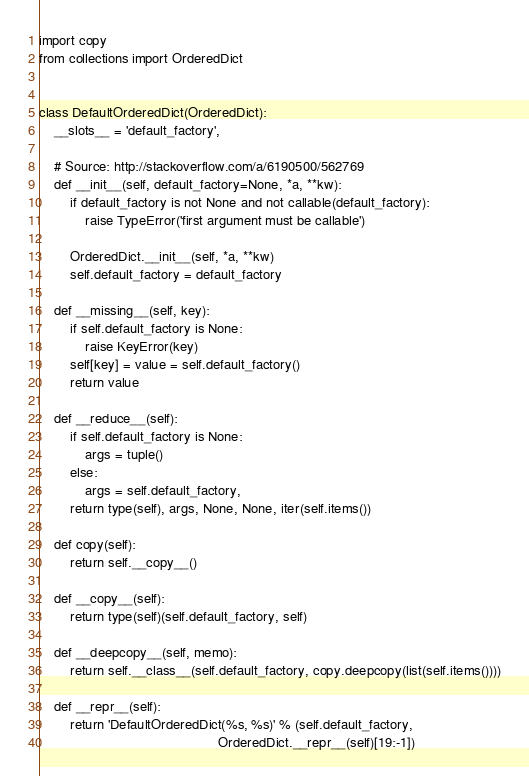<code> <loc_0><loc_0><loc_500><loc_500><_Python_>import copy
from collections import OrderedDict


class DefaultOrderedDict(OrderedDict):
    __slots__ = 'default_factory',

    # Source: http://stackoverflow.com/a/6190500/562769
    def __init__(self, default_factory=None, *a, **kw):
        if default_factory is not None and not callable(default_factory):
            raise TypeError('first argument must be callable')

        OrderedDict.__init__(self, *a, **kw)
        self.default_factory = default_factory

    def __missing__(self, key):
        if self.default_factory is None:
            raise KeyError(key)
        self[key] = value = self.default_factory()
        return value

    def __reduce__(self):
        if self.default_factory is None:
            args = tuple()
        else:
            args = self.default_factory,
        return type(self), args, None, None, iter(self.items())

    def copy(self):
        return self.__copy__()

    def __copy__(self):
        return type(self)(self.default_factory, self)

    def __deepcopy__(self, memo):
        return self.__class__(self.default_factory, copy.deepcopy(list(self.items())))

    def __repr__(self):
        return 'DefaultOrderedDict(%s, %s)' % (self.default_factory,
                                               OrderedDict.__repr__(self)[19:-1])
</code> 